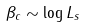<formula> <loc_0><loc_0><loc_500><loc_500>\beta _ { c } \sim \log L _ { s }</formula> 